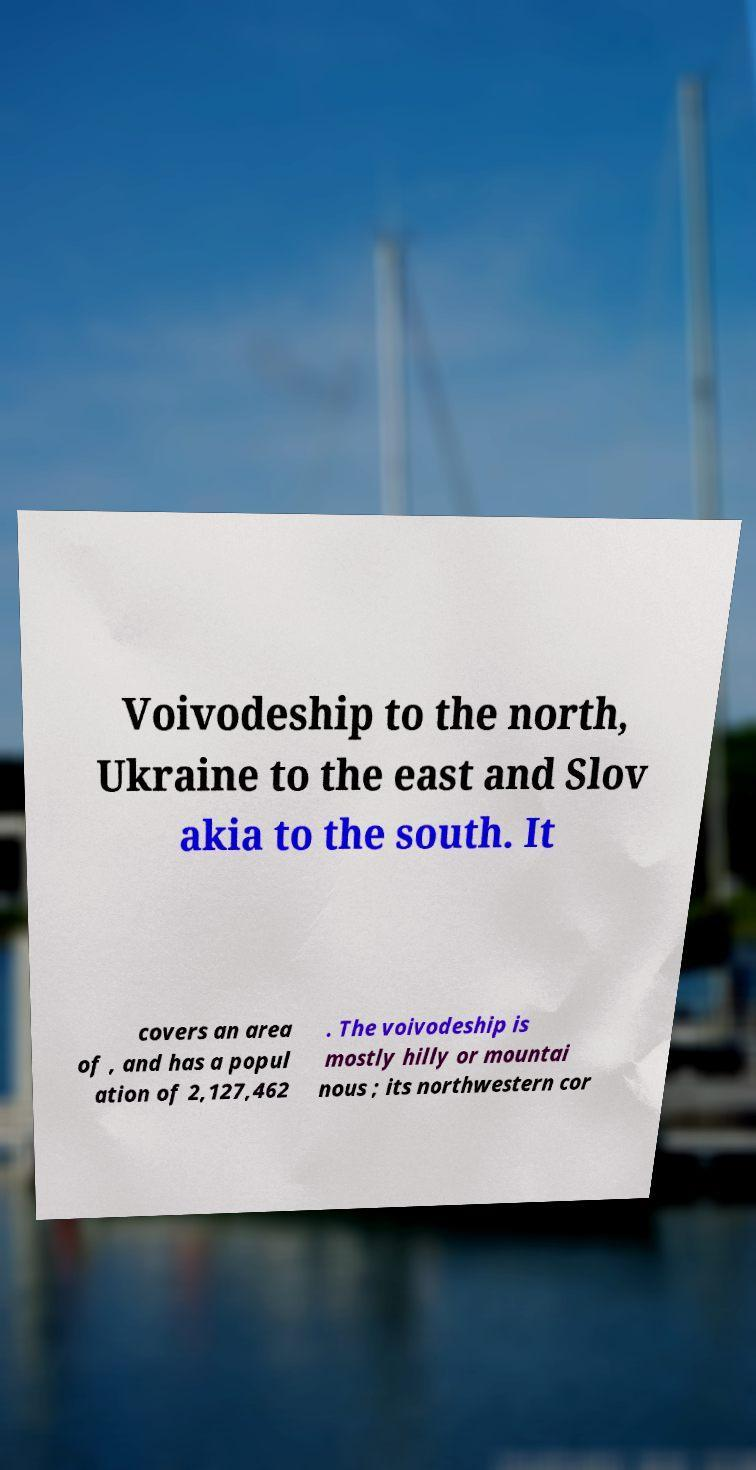Could you assist in decoding the text presented in this image and type it out clearly? Voivodeship to the north, Ukraine to the east and Slov akia to the south. It covers an area of , and has a popul ation of 2,127,462 . The voivodeship is mostly hilly or mountai nous ; its northwestern cor 